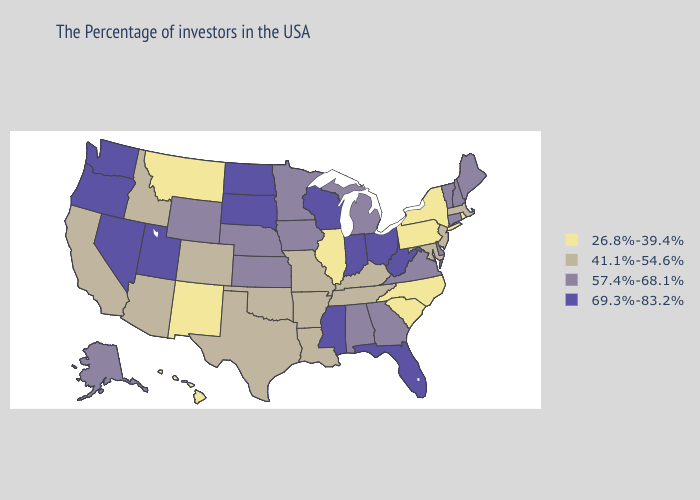Name the states that have a value in the range 26.8%-39.4%?
Write a very short answer. Rhode Island, New York, Pennsylvania, North Carolina, South Carolina, Illinois, New Mexico, Montana, Hawaii. What is the highest value in the South ?
Concise answer only. 69.3%-83.2%. Name the states that have a value in the range 69.3%-83.2%?
Keep it brief. West Virginia, Ohio, Florida, Indiana, Wisconsin, Mississippi, South Dakota, North Dakota, Utah, Nevada, Washington, Oregon. Is the legend a continuous bar?
Quick response, please. No. Does the map have missing data?
Be succinct. No. What is the value of New Jersey?
Short answer required. 41.1%-54.6%. What is the lowest value in the USA?
Be succinct. 26.8%-39.4%. What is the value of Texas?
Answer briefly. 41.1%-54.6%. Name the states that have a value in the range 41.1%-54.6%?
Give a very brief answer. Massachusetts, New Jersey, Maryland, Kentucky, Tennessee, Louisiana, Missouri, Arkansas, Oklahoma, Texas, Colorado, Arizona, Idaho, California. Is the legend a continuous bar?
Give a very brief answer. No. Name the states that have a value in the range 26.8%-39.4%?
Quick response, please. Rhode Island, New York, Pennsylvania, North Carolina, South Carolina, Illinois, New Mexico, Montana, Hawaii. What is the highest value in the South ?
Short answer required. 69.3%-83.2%. What is the value of Wisconsin?
Concise answer only. 69.3%-83.2%. Among the states that border Utah , does Nevada have the highest value?
Be succinct. Yes. Among the states that border South Carolina , which have the lowest value?
Quick response, please. North Carolina. 